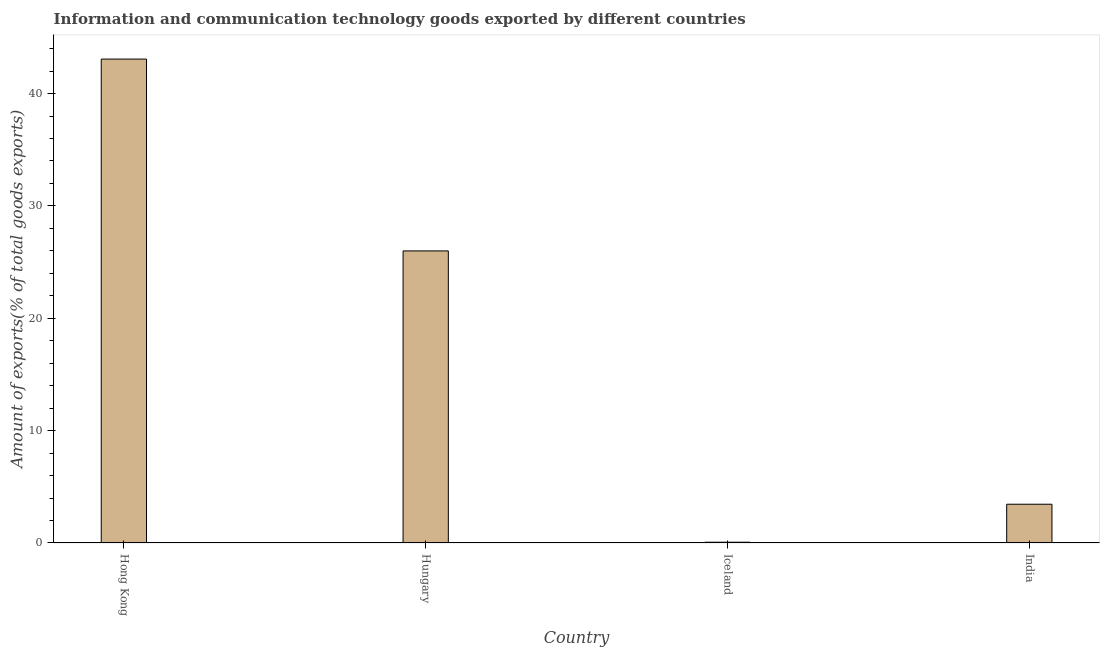Does the graph contain any zero values?
Provide a short and direct response. No. What is the title of the graph?
Keep it short and to the point. Information and communication technology goods exported by different countries. What is the label or title of the Y-axis?
Make the answer very short. Amount of exports(% of total goods exports). What is the amount of ict goods exports in India?
Offer a very short reply. 3.45. Across all countries, what is the maximum amount of ict goods exports?
Provide a succinct answer. 43.07. Across all countries, what is the minimum amount of ict goods exports?
Give a very brief answer. 0.07. In which country was the amount of ict goods exports maximum?
Keep it short and to the point. Hong Kong. What is the sum of the amount of ict goods exports?
Your answer should be very brief. 72.58. What is the difference between the amount of ict goods exports in Hong Kong and Hungary?
Offer a very short reply. 17.07. What is the average amount of ict goods exports per country?
Make the answer very short. 18.15. What is the median amount of ict goods exports?
Offer a very short reply. 14.72. What is the ratio of the amount of ict goods exports in Hong Kong to that in Hungary?
Give a very brief answer. 1.66. What is the difference between the highest and the second highest amount of ict goods exports?
Ensure brevity in your answer.  17.07. Is the sum of the amount of ict goods exports in Hungary and Iceland greater than the maximum amount of ict goods exports across all countries?
Offer a terse response. No. How many bars are there?
Make the answer very short. 4. How many countries are there in the graph?
Provide a short and direct response. 4. What is the difference between two consecutive major ticks on the Y-axis?
Your response must be concise. 10. What is the Amount of exports(% of total goods exports) in Hong Kong?
Your answer should be very brief. 43.07. What is the Amount of exports(% of total goods exports) of Hungary?
Your answer should be very brief. 26. What is the Amount of exports(% of total goods exports) of Iceland?
Provide a short and direct response. 0.07. What is the Amount of exports(% of total goods exports) in India?
Give a very brief answer. 3.45. What is the difference between the Amount of exports(% of total goods exports) in Hong Kong and Hungary?
Ensure brevity in your answer.  17.07. What is the difference between the Amount of exports(% of total goods exports) in Hong Kong and Iceland?
Make the answer very short. 43. What is the difference between the Amount of exports(% of total goods exports) in Hong Kong and India?
Give a very brief answer. 39.62. What is the difference between the Amount of exports(% of total goods exports) in Hungary and Iceland?
Make the answer very short. 25.93. What is the difference between the Amount of exports(% of total goods exports) in Hungary and India?
Your response must be concise. 22.55. What is the difference between the Amount of exports(% of total goods exports) in Iceland and India?
Your answer should be compact. -3.38. What is the ratio of the Amount of exports(% of total goods exports) in Hong Kong to that in Hungary?
Your answer should be compact. 1.66. What is the ratio of the Amount of exports(% of total goods exports) in Hong Kong to that in Iceland?
Give a very brief answer. 627.86. What is the ratio of the Amount of exports(% of total goods exports) in Hong Kong to that in India?
Offer a terse response. 12.48. What is the ratio of the Amount of exports(% of total goods exports) in Hungary to that in Iceland?
Keep it short and to the point. 378.95. What is the ratio of the Amount of exports(% of total goods exports) in Hungary to that in India?
Ensure brevity in your answer.  7.53. 